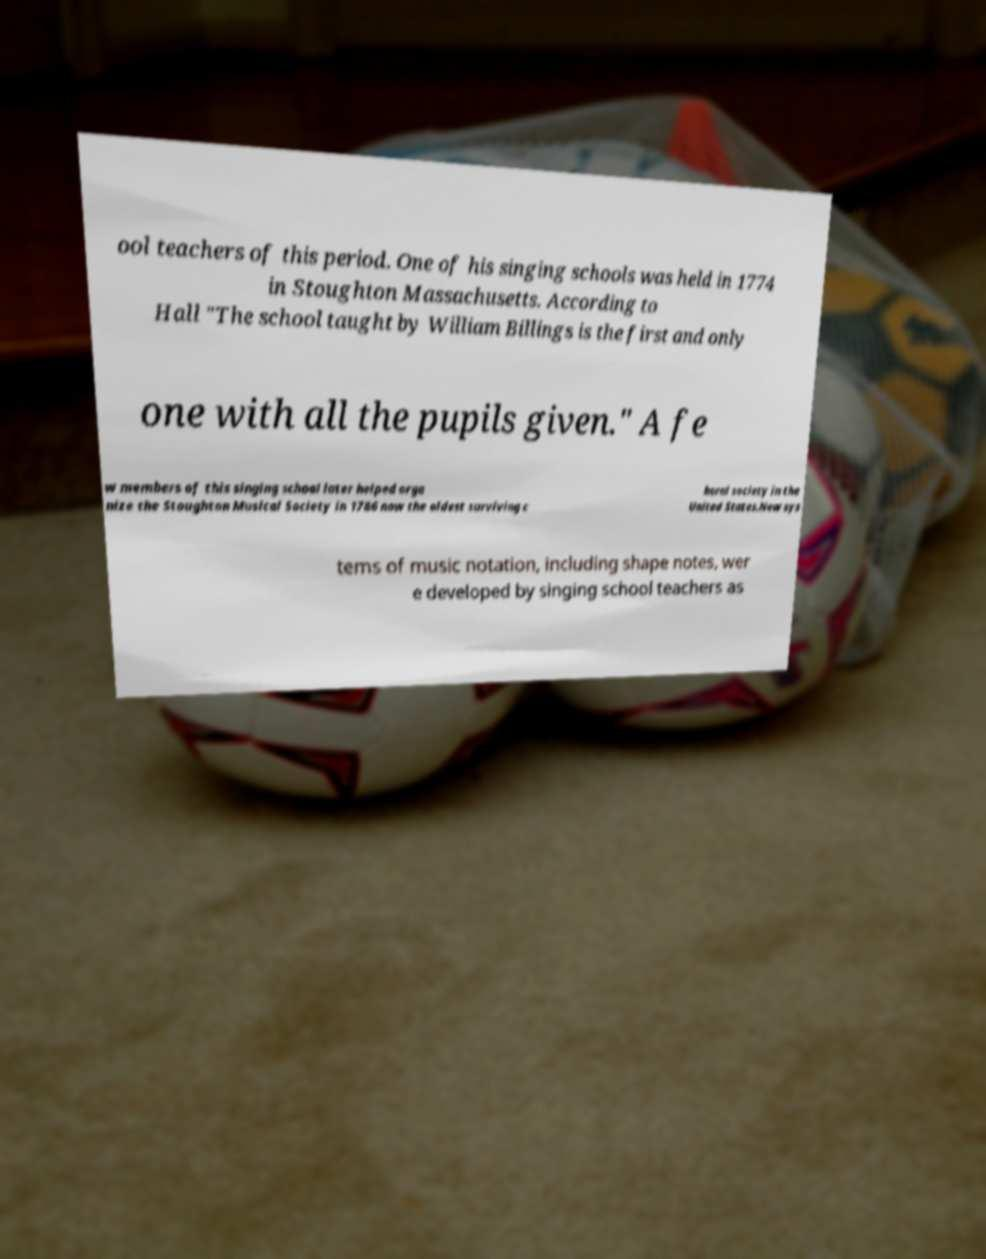Could you assist in decoding the text presented in this image and type it out clearly? ool teachers of this period. One of his singing schools was held in 1774 in Stoughton Massachusetts. According to Hall "The school taught by William Billings is the first and only one with all the pupils given." A fe w members of this singing school later helped orga nize the Stoughton Musical Society in 1786 now the oldest surviving c horal society in the United States.New sys tems of music notation, including shape notes, wer e developed by singing school teachers as 